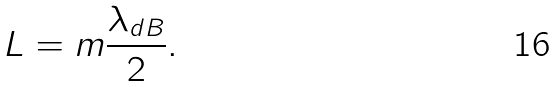<formula> <loc_0><loc_0><loc_500><loc_500>L = m \frac { \lambda _ { d B } } { 2 } .</formula> 